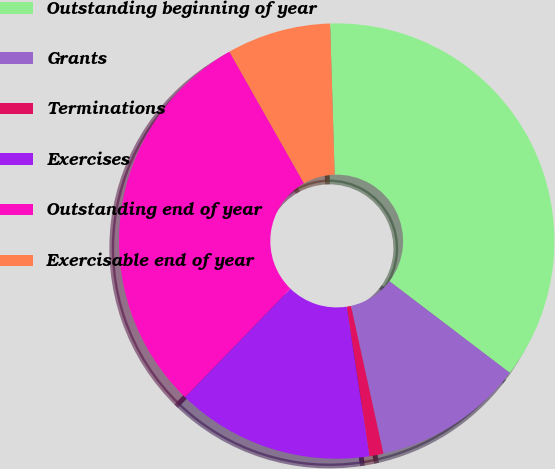Convert chart. <chart><loc_0><loc_0><loc_500><loc_500><pie_chart><fcel>Outstanding beginning of year<fcel>Grants<fcel>Terminations<fcel>Exercises<fcel>Outstanding end of year<fcel>Exercisable end of year<nl><fcel>35.84%<fcel>11.2%<fcel>1.04%<fcel>14.67%<fcel>29.53%<fcel>7.72%<nl></chart> 